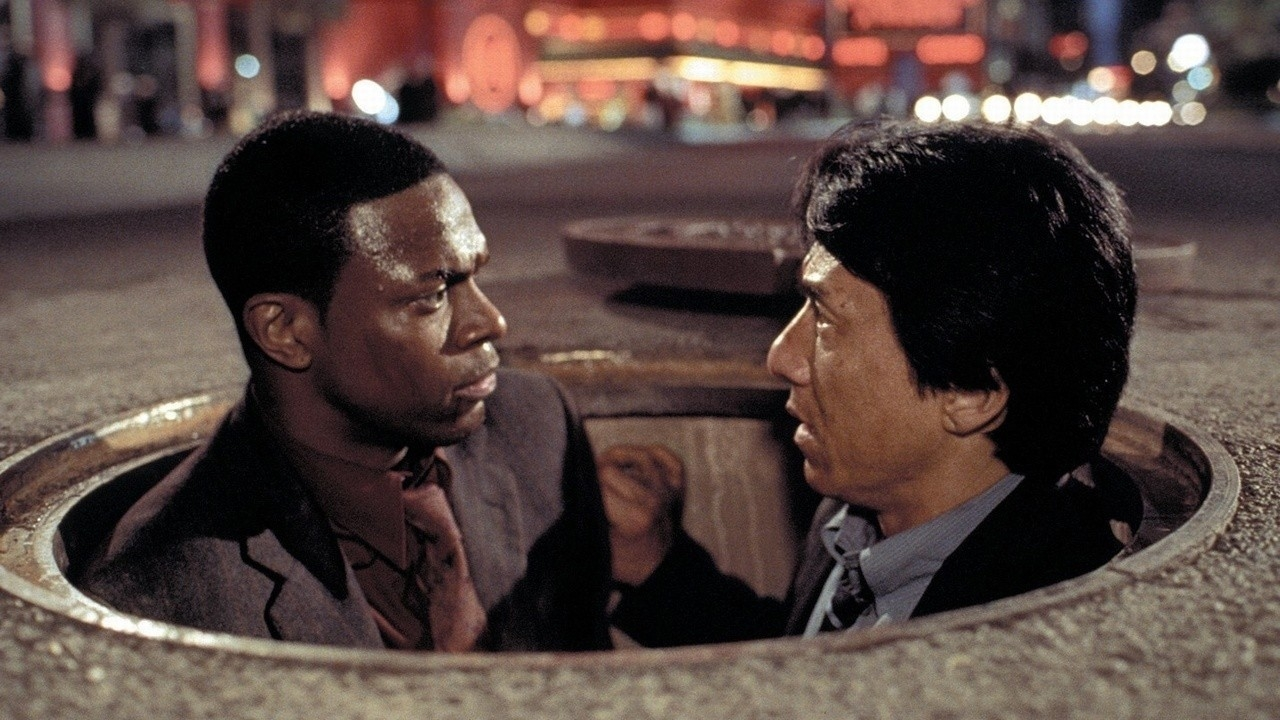Imagine if these characters suddenly found a treasure map in the manhole. What would they do next? Discovering a treasure map in the manhole, Chris Tucker and Jackie Chan’s characters would initially be skeptical, but quickly their curiosity gets the better of them. They analyze the map, which details a series of underground tunnels leading to a hidden vault beneath the city. The mood shifts from tension to excitement as they decide to follow the trail. Along the way, they encounter a series of booby traps and coded messages. Using their combined skills – Chan’s agility and Tucker’s witty problem-solving – they make progress. Throughout this journey, their bond grows stronger, and they become an unbeatable team, uncovering secrets that the city had buried long ago. 